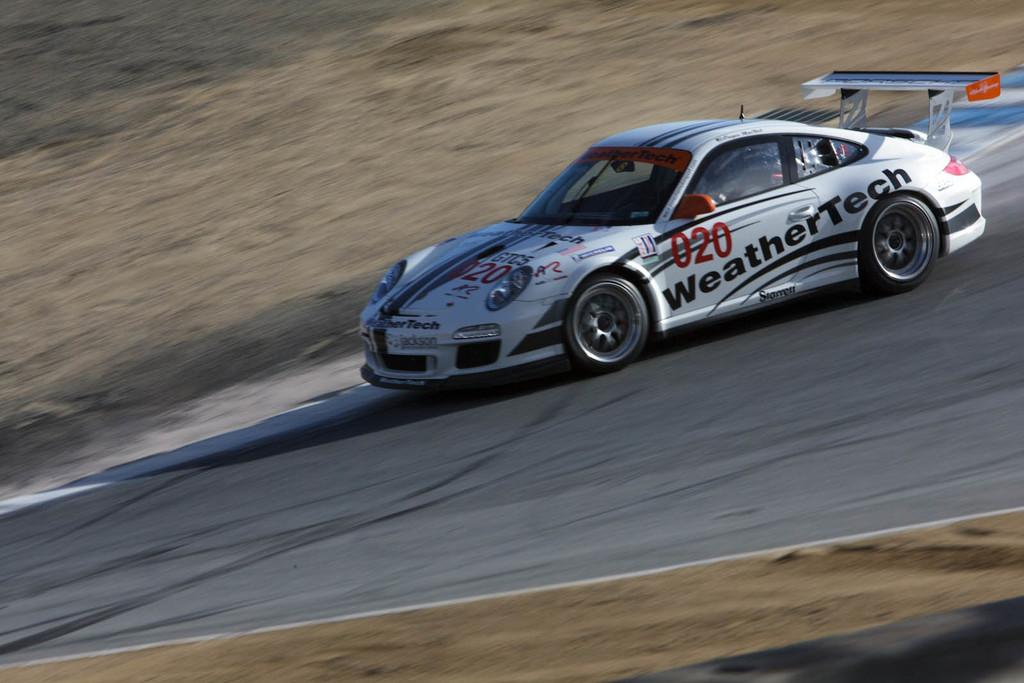What is the main subject of the image? The main subject of the image is a car. What is the car doing in the image? The car is travelling on a road in the image. What features can be seen on the car? The car has a windshield, wipers, wheels, and a mirror. What type of boundary can be seen surrounding the earth in the image? There is no image of the earth or any boundaries in the image; it features a car travelling on a road. 